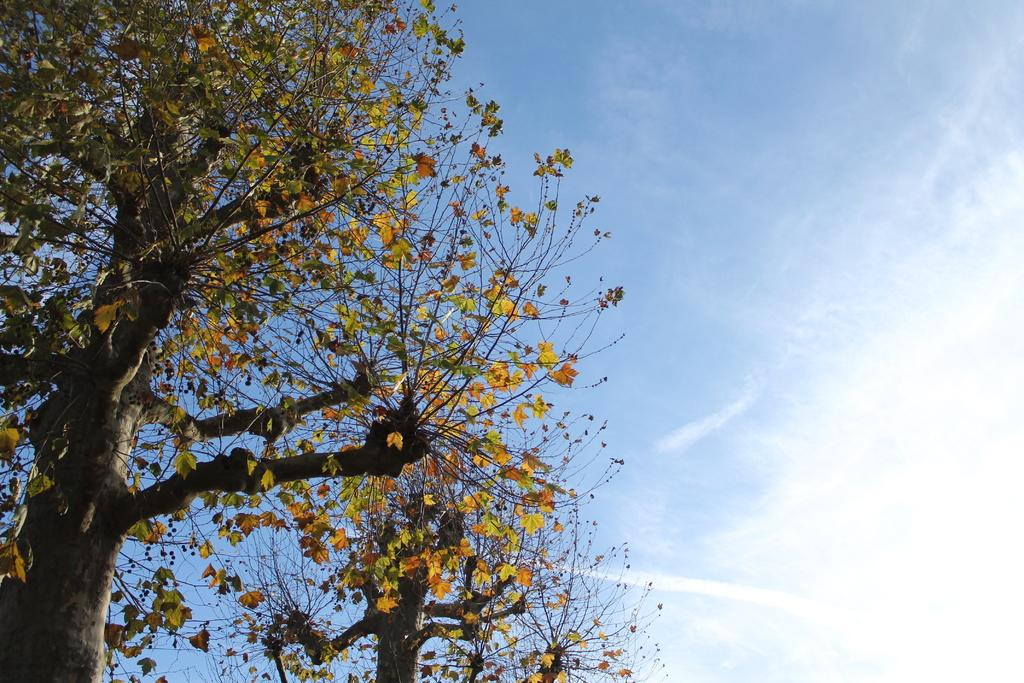What type of vegetation can be seen in the image? There are trees in the image. What is visible in the background of the image? The sky is visible in the image. What can be observed in the sky? Clouds are present in the sky. How many chickens can be seen in the image? There are no chickens present in the image. What type of tool is being used by the ducks in the image? There are no ducks or tools present in the image. 